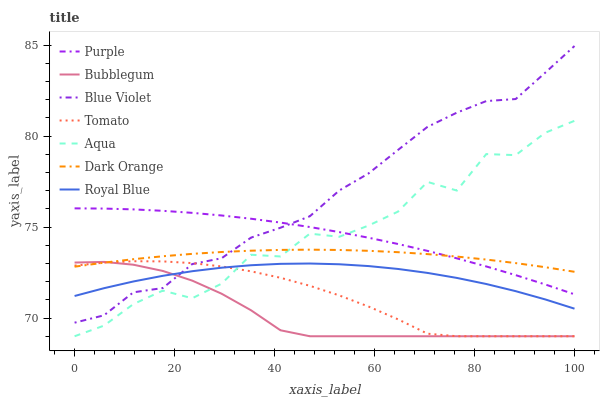Does Bubblegum have the minimum area under the curve?
Answer yes or no. Yes. Does Blue Violet have the maximum area under the curve?
Answer yes or no. Yes. Does Dark Orange have the minimum area under the curve?
Answer yes or no. No. Does Dark Orange have the maximum area under the curve?
Answer yes or no. No. Is Dark Orange the smoothest?
Answer yes or no. Yes. Is Aqua the roughest?
Answer yes or no. Yes. Is Purple the smoothest?
Answer yes or no. No. Is Purple the roughest?
Answer yes or no. No. Does Tomato have the lowest value?
Answer yes or no. Yes. Does Purple have the lowest value?
Answer yes or no. No. Does Blue Violet have the highest value?
Answer yes or no. Yes. Does Dark Orange have the highest value?
Answer yes or no. No. Is Tomato less than Purple?
Answer yes or no. Yes. Is Dark Orange greater than Royal Blue?
Answer yes or no. Yes. Does Aqua intersect Tomato?
Answer yes or no. Yes. Is Aqua less than Tomato?
Answer yes or no. No. Is Aqua greater than Tomato?
Answer yes or no. No. Does Tomato intersect Purple?
Answer yes or no. No. 